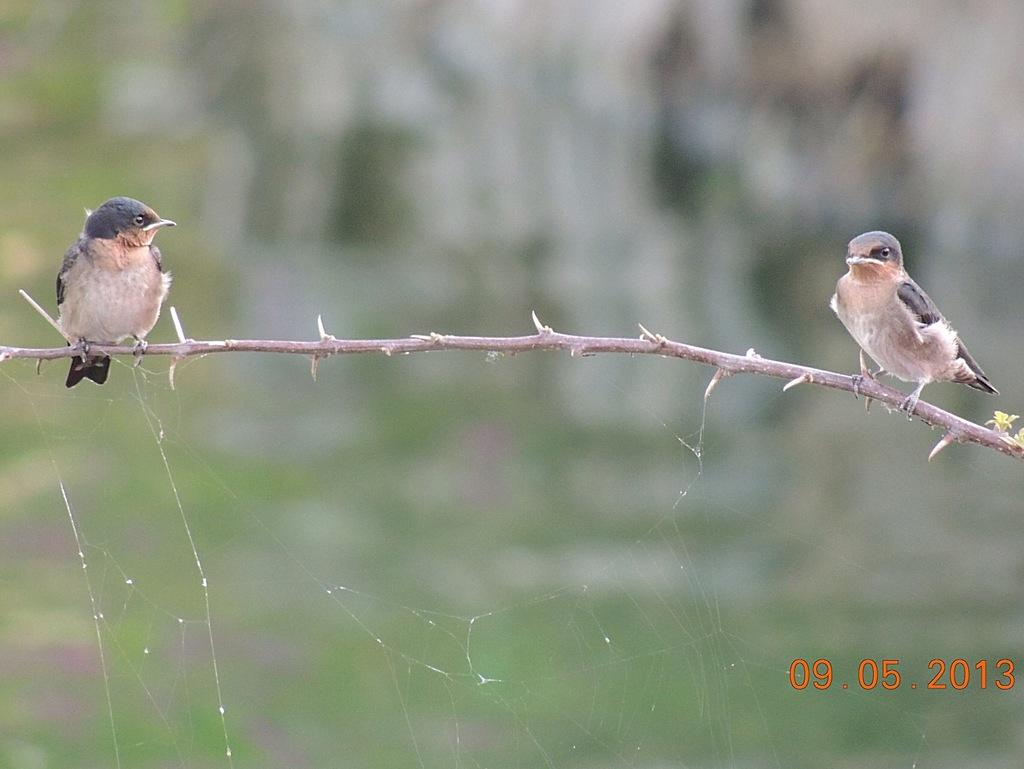How many birds are present in the image? There are two birds in the image. What are the birds doing in the image? The birds are sitting on a stem. Is there any text or information at the bottom of the image? Yes, there is a date at the bottom of the image. Are there any slaves visible in the image? There are no slaves present in the image; it features two birds sitting on a stem. Can you see any pests in the image? There is no mention of pests in the image, as it only shows two birds sitting on a stem. 